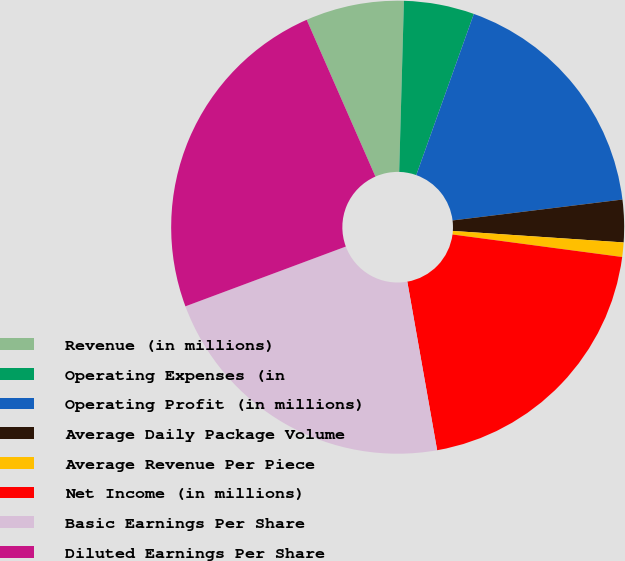Convert chart. <chart><loc_0><loc_0><loc_500><loc_500><pie_chart><fcel>Revenue (in millions)<fcel>Operating Expenses (in<fcel>Operating Profit (in millions)<fcel>Average Daily Package Volume<fcel>Average Revenue Per Piece<fcel>Net Income (in millions)<fcel>Basic Earnings Per Share<fcel>Diluted Earnings Per Share<nl><fcel>7.02%<fcel>5.02%<fcel>17.59%<fcel>3.02%<fcel>1.03%<fcel>20.11%<fcel>22.11%<fcel>24.1%<nl></chart> 